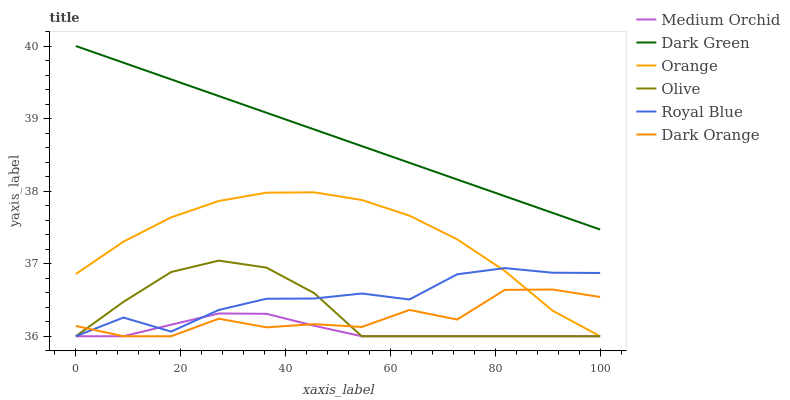Does Medium Orchid have the minimum area under the curve?
Answer yes or no. Yes. Does Dark Green have the maximum area under the curve?
Answer yes or no. Yes. Does Royal Blue have the minimum area under the curve?
Answer yes or no. No. Does Royal Blue have the maximum area under the curve?
Answer yes or no. No. Is Dark Green the smoothest?
Answer yes or no. Yes. Is Dark Orange the roughest?
Answer yes or no. Yes. Is Royal Blue the smoothest?
Answer yes or no. No. Is Royal Blue the roughest?
Answer yes or no. No. Does Dark Green have the lowest value?
Answer yes or no. No. Does Dark Green have the highest value?
Answer yes or no. Yes. Does Royal Blue have the highest value?
Answer yes or no. No. Is Dark Orange less than Dark Green?
Answer yes or no. Yes. Is Dark Green greater than Orange?
Answer yes or no. Yes. Does Dark Orange intersect Dark Green?
Answer yes or no. No. 